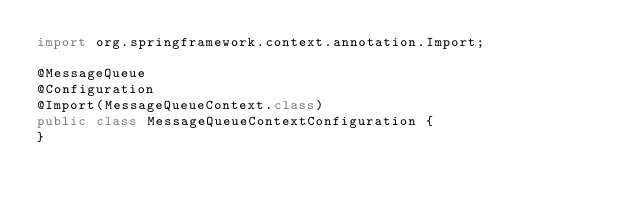<code> <loc_0><loc_0><loc_500><loc_500><_Java_>import org.springframework.context.annotation.Import;

@MessageQueue
@Configuration
@Import(MessageQueueContext.class)
public class MessageQueueContextConfiguration {
}
</code> 